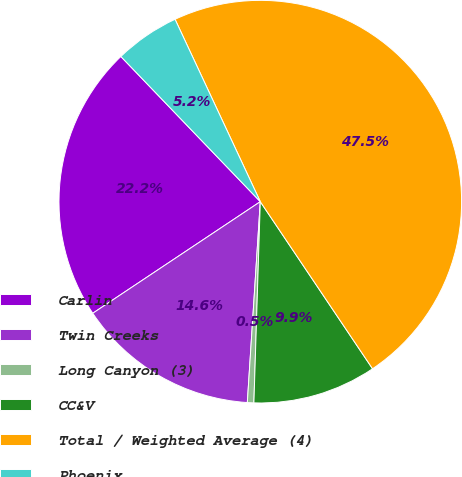Convert chart. <chart><loc_0><loc_0><loc_500><loc_500><pie_chart><fcel>Carlin<fcel>Twin Creeks<fcel>Long Canyon (3)<fcel>CC&V<fcel>Total / Weighted Average (4)<fcel>Phoenix<nl><fcel>22.17%<fcel>14.62%<fcel>0.52%<fcel>9.92%<fcel>47.54%<fcel>5.22%<nl></chart> 